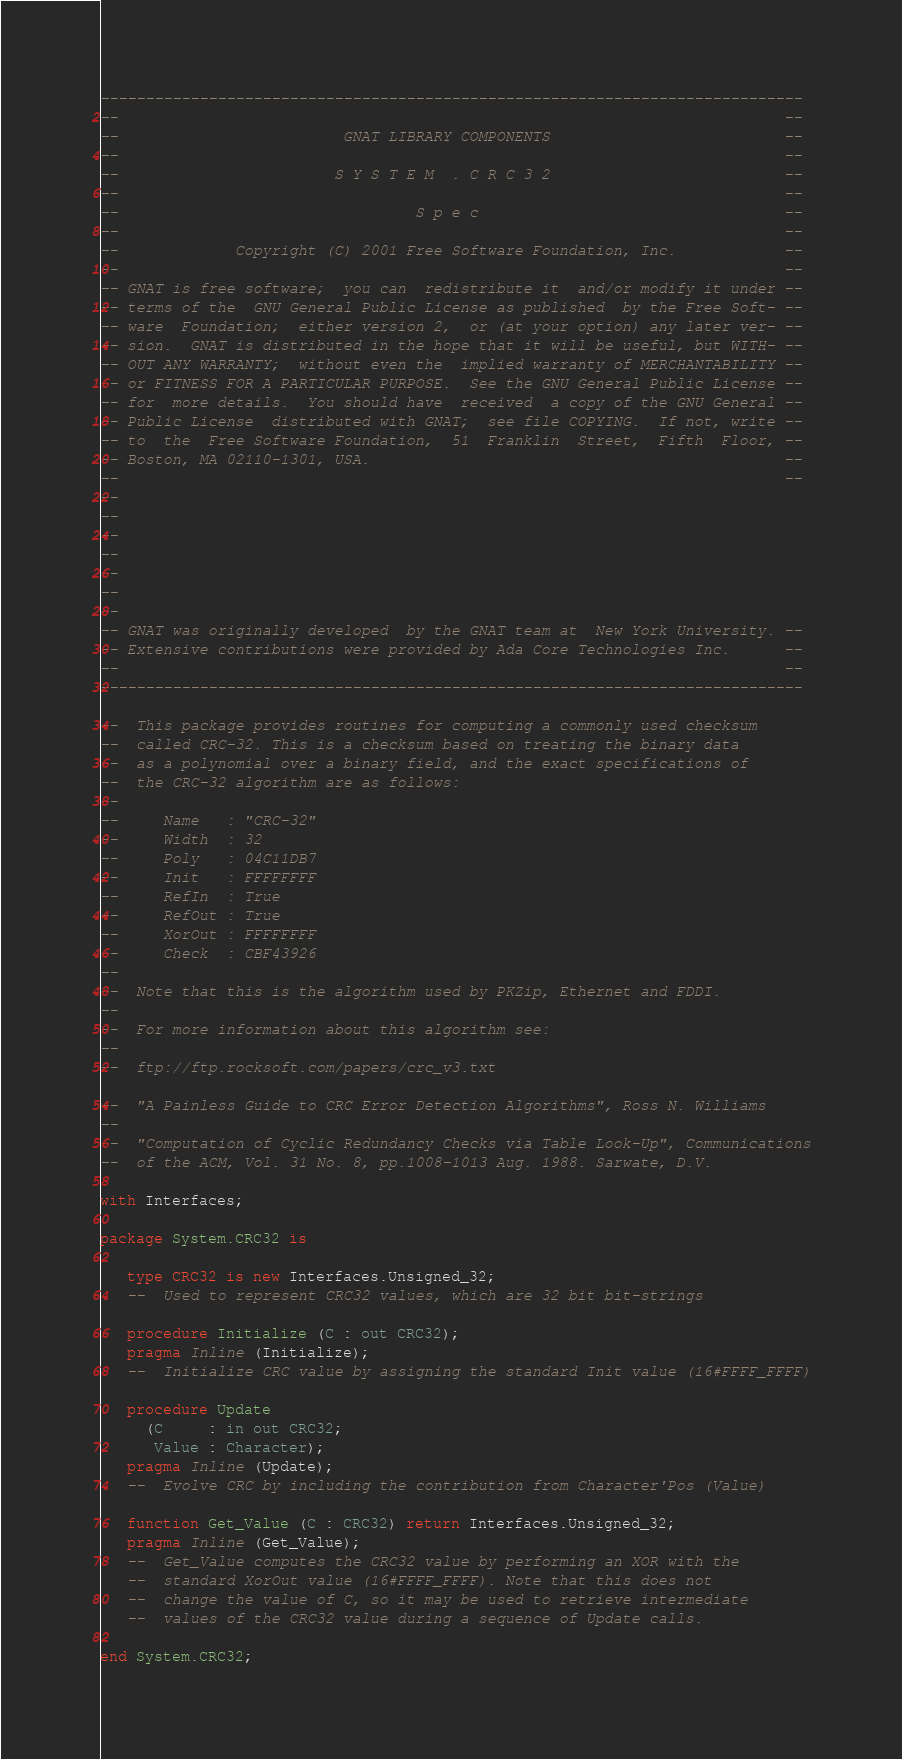Convert code to text. <code><loc_0><loc_0><loc_500><loc_500><_Ada_>------------------------------------------------------------------------------
--                                                                          --
--                         GNAT LIBRARY COMPONENTS                          --
--                                                                          --
--                        S Y S T E M  . C R C 3 2                          --
--                                                                          --
--                                 S p e c                                  --
--                                                                          --
--             Copyright (C) 2001 Free Software Foundation, Inc.            --
--                                                                          --
-- GNAT is free software;  you can  redistribute it  and/or modify it under --
-- terms of the  GNU General Public License as published  by the Free Soft- --
-- ware  Foundation;  either version 2,  or (at your option) any later ver- --
-- sion.  GNAT is distributed in the hope that it will be useful, but WITH- --
-- OUT ANY WARRANTY;  without even the  implied warranty of MERCHANTABILITY --
-- or FITNESS FOR A PARTICULAR PURPOSE.  See the GNU General Public License --
-- for  more details.  You should have  received  a copy of the GNU General --
-- Public License  distributed with GNAT;  see file COPYING.  If not, write --
-- to  the  Free Software Foundation,  51  Franklin  Street,  Fifth  Floor, --
-- Boston, MA 02110-1301, USA.                                              --
--                                                                          --
--
--
--
--
--
--
--
-- GNAT was originally developed  by the GNAT team at  New York University. --
-- Extensive contributions were provided by Ada Core Technologies Inc.      --
--                                                                          --
------------------------------------------------------------------------------

--  This package provides routines for computing a commonly used checksum
--  called CRC-32. This is a checksum based on treating the binary data
--  as a polynomial over a binary field, and the exact specifications of
--  the CRC-32 algorithm are as follows:
--
--     Name   : "CRC-32"
--     Width  : 32
--     Poly   : 04C11DB7
--     Init   : FFFFFFFF
--     RefIn  : True
--     RefOut : True
--     XorOut : FFFFFFFF
--     Check  : CBF43926
--
--  Note that this is the algorithm used by PKZip, Ethernet and FDDI.
--
--  For more information about this algorithm see:
--
--  ftp://ftp.rocksoft.com/papers/crc_v3.txt

--  "A Painless Guide to CRC Error Detection Algorithms", Ross N. Williams
--
--  "Computation of Cyclic Redundancy Checks via Table Look-Up", Communications
--  of the ACM, Vol. 31 No. 8, pp.1008-1013 Aug. 1988. Sarwate, D.V.

with Interfaces;

package System.CRC32 is

   type CRC32 is new Interfaces.Unsigned_32;
   --  Used to represent CRC32 values, which are 32 bit bit-strings

   procedure Initialize (C : out CRC32);
   pragma Inline (Initialize);
   --  Initialize CRC value by assigning the standard Init value (16#FFFF_FFFF)

   procedure Update
     (C     : in out CRC32;
      Value : Character);
   pragma Inline (Update);
   --  Evolve CRC by including the contribution from Character'Pos (Value)

   function Get_Value (C : CRC32) return Interfaces.Unsigned_32;
   pragma Inline (Get_Value);
   --  Get_Value computes the CRC32 value by performing an XOR with the
   --  standard XorOut value (16#FFFF_FFFF). Note that this does not
   --  change the value of C, so it may be used to retrieve intermediate
   --  values of the CRC32 value during a sequence of Update calls.

end System.CRC32;
</code> 